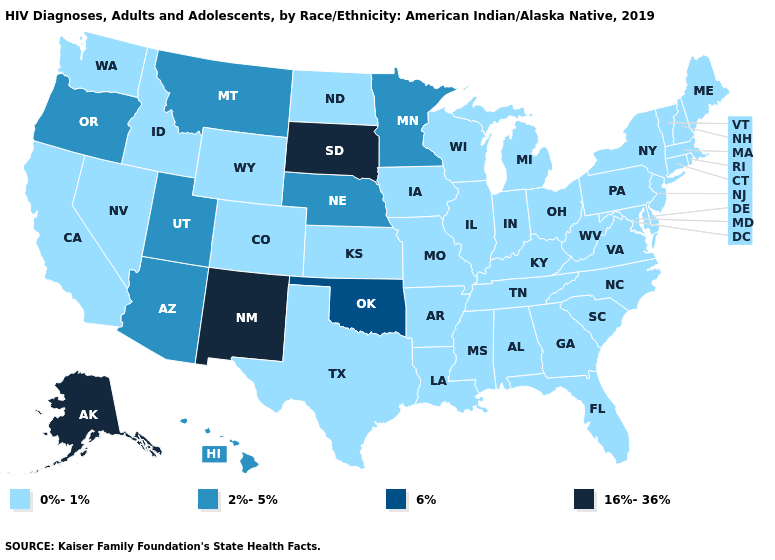What is the highest value in the Northeast ?
Keep it brief. 0%-1%. Name the states that have a value in the range 0%-1%?
Keep it brief. Alabama, Arkansas, California, Colorado, Connecticut, Delaware, Florida, Georgia, Idaho, Illinois, Indiana, Iowa, Kansas, Kentucky, Louisiana, Maine, Maryland, Massachusetts, Michigan, Mississippi, Missouri, Nevada, New Hampshire, New Jersey, New York, North Carolina, North Dakota, Ohio, Pennsylvania, Rhode Island, South Carolina, Tennessee, Texas, Vermont, Virginia, Washington, West Virginia, Wisconsin, Wyoming. What is the value of Indiana?
Answer briefly. 0%-1%. Does Massachusetts have a higher value than Florida?
Write a very short answer. No. Does New Mexico have the highest value in the West?
Concise answer only. Yes. Does South Dakota have the highest value in the MidWest?
Keep it brief. Yes. Does the first symbol in the legend represent the smallest category?
Be succinct. Yes. What is the value of Idaho?
Be succinct. 0%-1%. What is the highest value in the USA?
Short answer required. 16%-36%. Does Georgia have a higher value than South Carolina?
Write a very short answer. No. Is the legend a continuous bar?
Short answer required. No. What is the highest value in the USA?
Write a very short answer. 16%-36%. Does the map have missing data?
Give a very brief answer. No. Name the states that have a value in the range 0%-1%?
Be succinct. Alabama, Arkansas, California, Colorado, Connecticut, Delaware, Florida, Georgia, Idaho, Illinois, Indiana, Iowa, Kansas, Kentucky, Louisiana, Maine, Maryland, Massachusetts, Michigan, Mississippi, Missouri, Nevada, New Hampshire, New Jersey, New York, North Carolina, North Dakota, Ohio, Pennsylvania, Rhode Island, South Carolina, Tennessee, Texas, Vermont, Virginia, Washington, West Virginia, Wisconsin, Wyoming. What is the highest value in the USA?
Give a very brief answer. 16%-36%. 